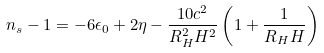<formula> <loc_0><loc_0><loc_500><loc_500>n _ { s } - 1 = - 6 \epsilon _ { 0 } + 2 \eta - \frac { 1 0 c ^ { 2 } } { R _ { H } ^ { 2 } H ^ { 2 } } \left ( 1 + \frac { 1 } { R _ { H } H } \right )</formula> 